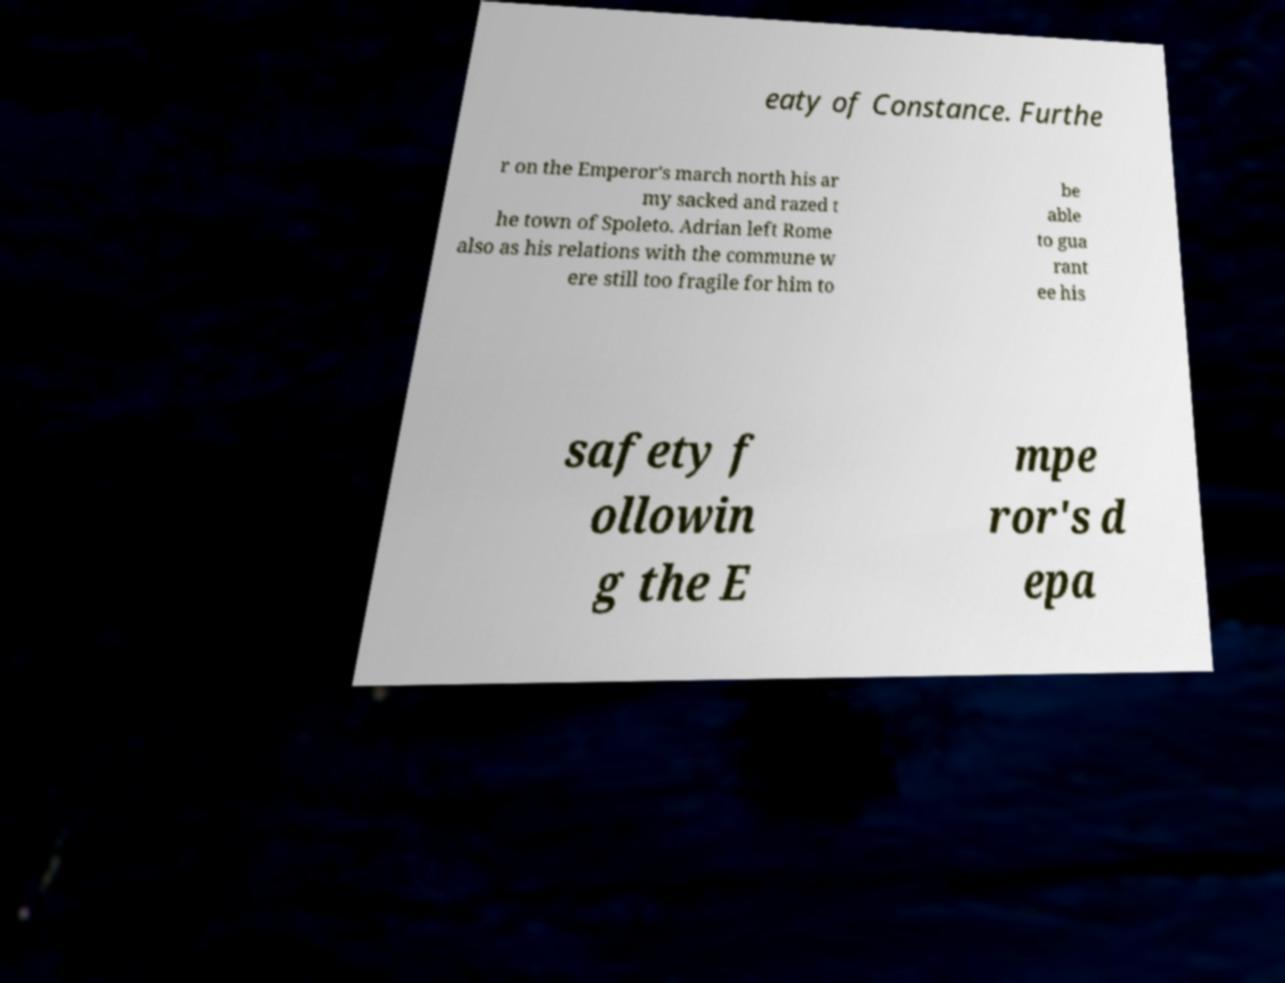Please identify and transcribe the text found in this image. eaty of Constance. Furthe r on the Emperor's march north his ar my sacked and razed t he town of Spoleto. Adrian left Rome also as his relations with the commune w ere still too fragile for him to be able to gua rant ee his safety f ollowin g the E mpe ror's d epa 